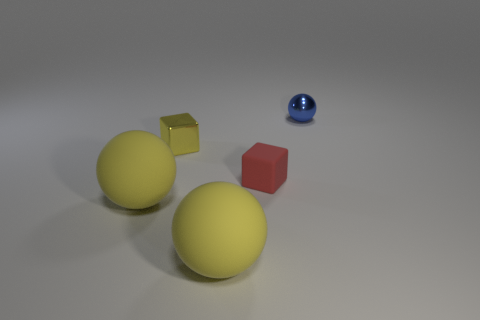What can the positioning of these objects tell us about the perspective and depth of the scene? The arrangement of the objects creates a sense of three-dimensional space. The larger yellow spheres are in the foreground, with their size contributing to the illusion of depth. The smaller red cube and blue sphere are positioned further back, enhancing the perspective. This setup gives a clear indication of the spatial dynamics within the scene. 